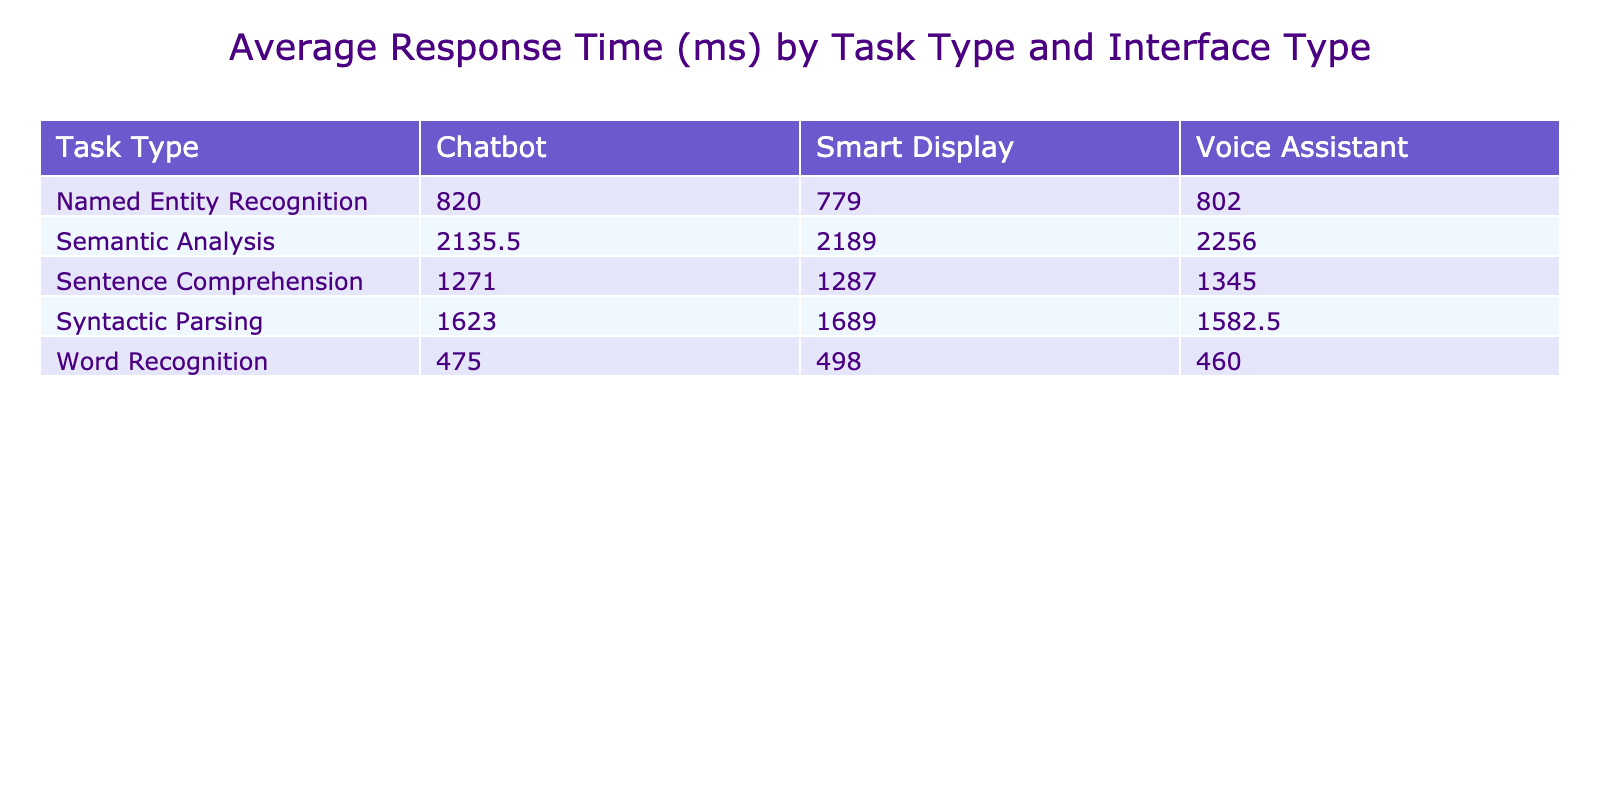What is the average response time for Word Recognition tasks using Voice Assistant? The average response time for Word Recognition with Voice Assistant can be found in the table under the respective column. The recorded response time is 452 ms.
Answer: 452 ms Which task type has the longest average response time? Looking at the average response times from the table, Semantic Analysis shows the highest value at 2256 ms.
Answer: Semantic Analysis Is the response time for Named Entity Recognition using Smart Display greater than that for Word Recognition using Chatbot? Checking the response times, Named Entity Recognition using Smart Display has 820 ms and Word Recognition using Chatbot has 475 ms. Since 820 ms is greater than 475 ms, the answer is yes.
Answer: Yes What is the difference in average response time between Syntactic Parsing on Voice Assistant and Smart Display? The average response time for Syntactic Parsing on Voice Assistant is 1598 ms, while on Smart Display it is 1689 ms. The difference, therefore, is 1689 ms - 1598 ms = 91 ms.
Answer: 91 ms How does the average accuracy for tasks differ between the Voice Assistant and Chatbot interfaces? Calculating the average accuracy for Voice Assistant: (95 + 86 + 90 + 83 + 76) / 5 = 86. The average accuracy for Chatbot: (88 + 85 + 90 + 91 + 78) / 5 = 86. Thus, the averages are equal.
Answer: The averages are equal 